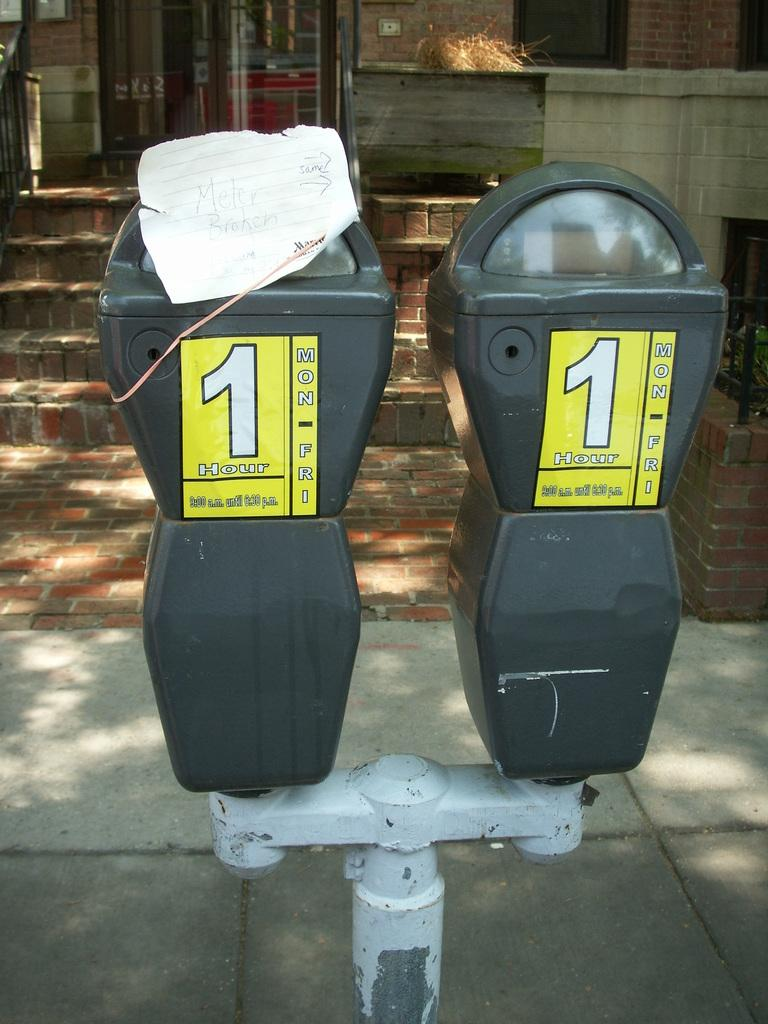<image>
Present a compact description of the photo's key features. two parking meeters with the number ones on them for an hour 